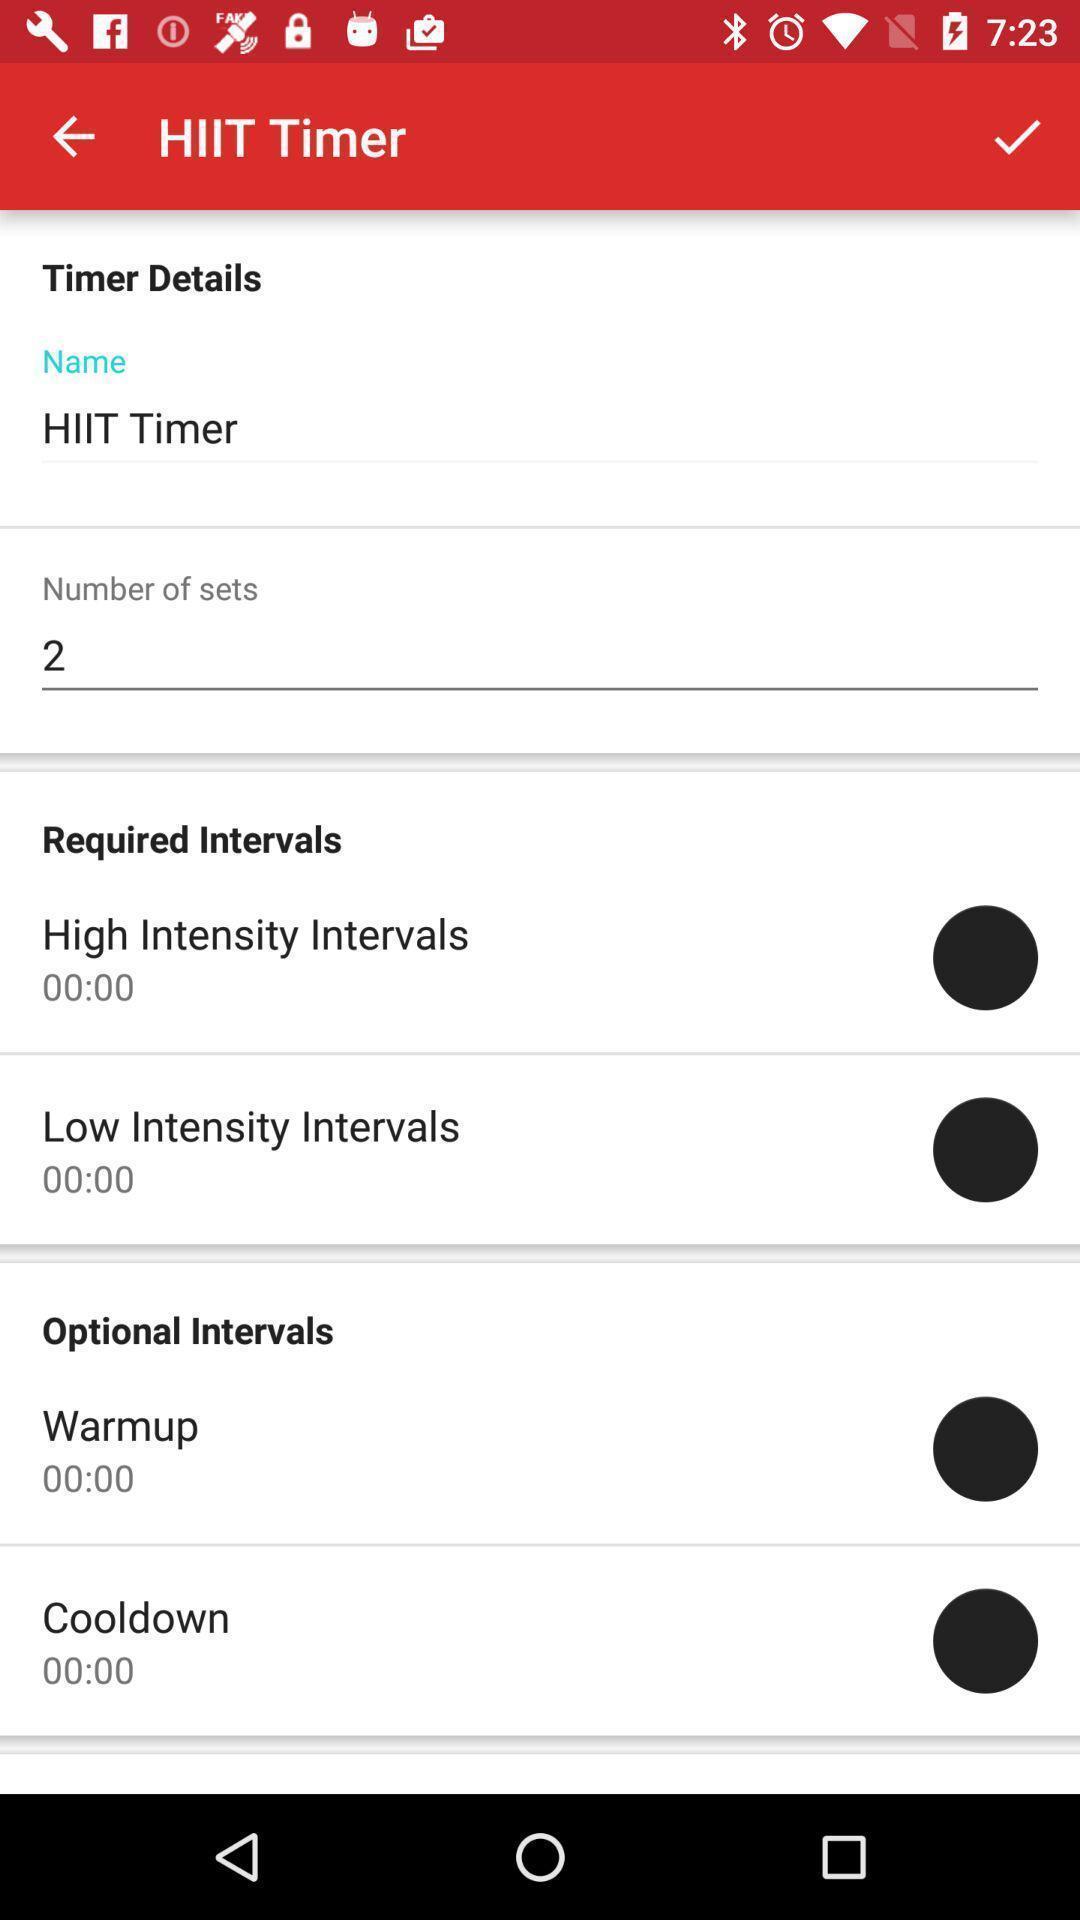Give me a narrative description of this picture. Screen showing about timer details. 